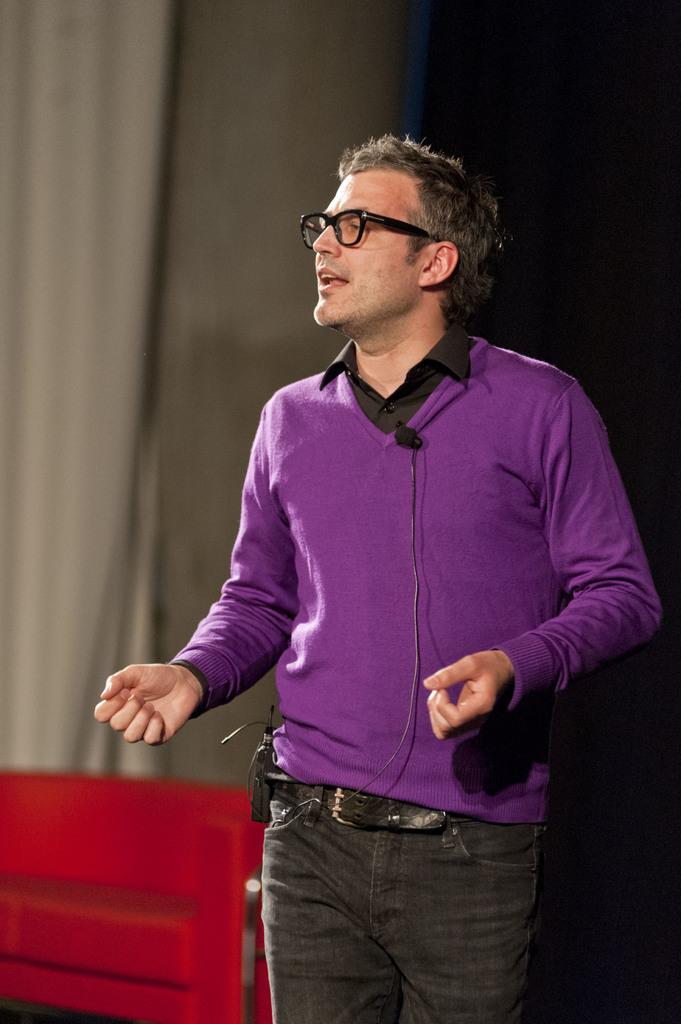What is the main subject of the image? There is a man standing in the center of the image. Can you describe the man's appearance? The man is wearing spectacles. What can be seen in the background of the image? There is a curtain in the background of the image. Where is the bench located in the image? The bench is in the bottom left corner of the image. What type of cable is the man holding in the image? There is no cable present in the image; the man is not holding anything. What sound can be heard coming from the man in the image? There is no sound associated with the man in the image, as it is a still photograph. 